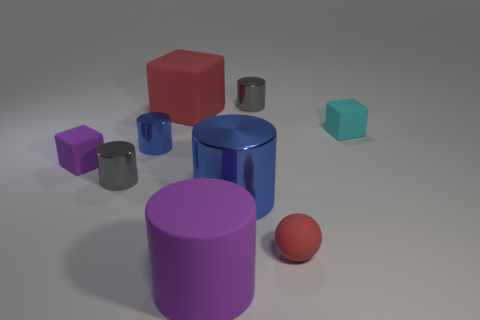Subtract 2 cylinders. How many cylinders are left? 3 Subtract all small blue cylinders. How many cylinders are left? 4 Subtract all gray cylinders. How many cylinders are left? 3 Subtract all yellow cylinders. Subtract all green spheres. How many cylinders are left? 5 Subtract all cubes. How many objects are left? 6 Add 9 large red rubber cubes. How many large red rubber cubes exist? 10 Subtract 1 red blocks. How many objects are left? 8 Subtract all red matte blocks. Subtract all tiny gray metallic cylinders. How many objects are left? 6 Add 9 small purple rubber objects. How many small purple rubber objects are left? 10 